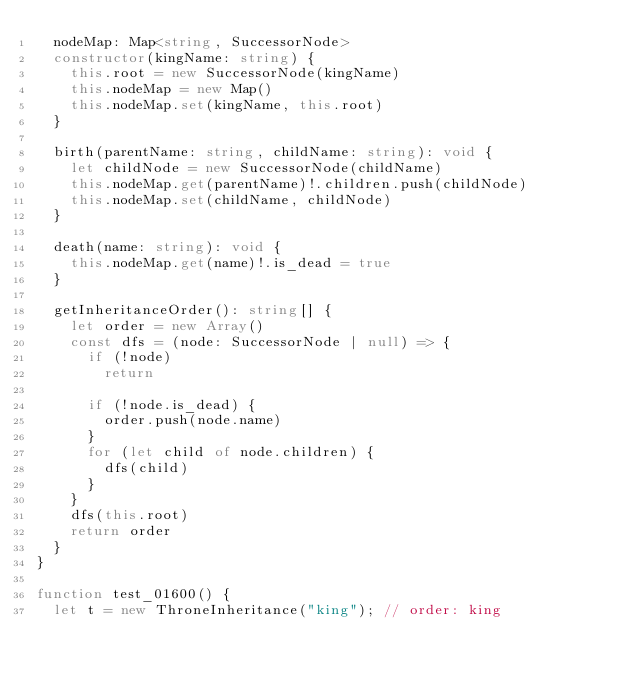<code> <loc_0><loc_0><loc_500><loc_500><_TypeScript_>  nodeMap: Map<string, SuccessorNode>
  constructor(kingName: string) {
    this.root = new SuccessorNode(kingName)
    this.nodeMap = new Map()
    this.nodeMap.set(kingName, this.root)
  }

  birth(parentName: string, childName: string): void {
    let childNode = new SuccessorNode(childName)
    this.nodeMap.get(parentName)!.children.push(childNode)
    this.nodeMap.set(childName, childNode)
  }

  death(name: string): void {
    this.nodeMap.get(name)!.is_dead = true
  }

  getInheritanceOrder(): string[] {
    let order = new Array()
    const dfs = (node: SuccessorNode | null) => {
      if (!node)
        return

      if (!node.is_dead) {
        order.push(node.name)
      }
      for (let child of node.children) {
        dfs(child)
      }
    }
    dfs(this.root)
    return order
  }
}

function test_01600() {
  let t = new ThroneInheritance("king"); // order: king</code> 